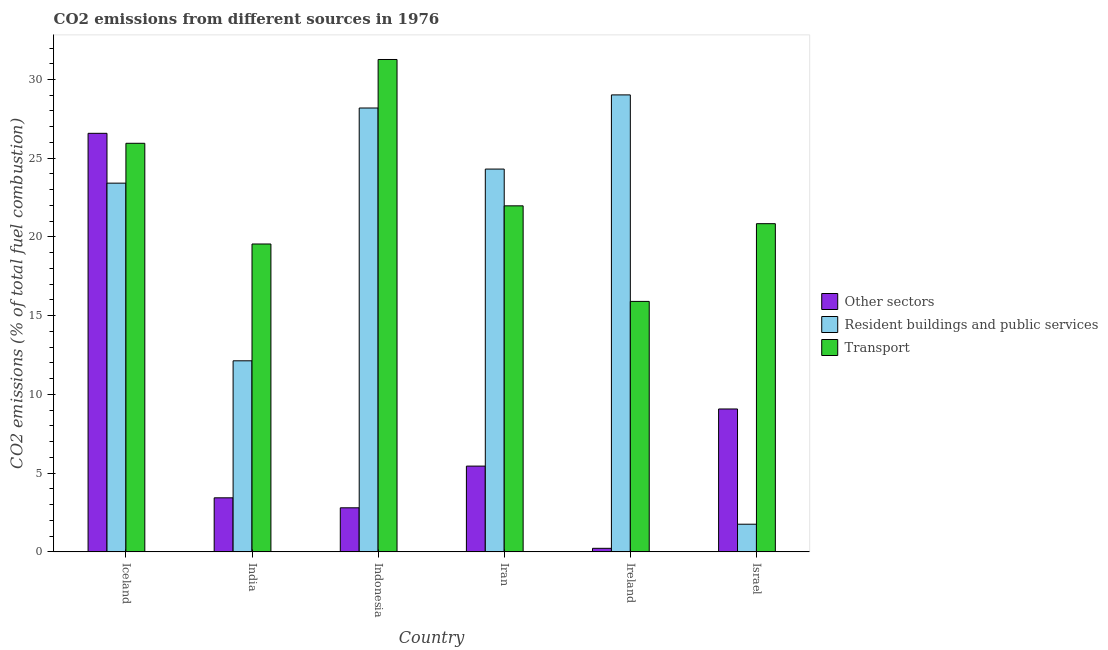How many different coloured bars are there?
Make the answer very short. 3. How many groups of bars are there?
Provide a succinct answer. 6. Are the number of bars per tick equal to the number of legend labels?
Provide a succinct answer. Yes. Are the number of bars on each tick of the X-axis equal?
Keep it short and to the point. Yes. How many bars are there on the 6th tick from the right?
Offer a terse response. 3. What is the label of the 6th group of bars from the left?
Provide a succinct answer. Israel. What is the percentage of co2 emissions from transport in Indonesia?
Your response must be concise. 31.27. Across all countries, what is the maximum percentage of co2 emissions from transport?
Give a very brief answer. 31.27. Across all countries, what is the minimum percentage of co2 emissions from transport?
Your response must be concise. 15.91. In which country was the percentage of co2 emissions from resident buildings and public services maximum?
Your response must be concise. Ireland. In which country was the percentage of co2 emissions from resident buildings and public services minimum?
Provide a succinct answer. Israel. What is the total percentage of co2 emissions from other sectors in the graph?
Your response must be concise. 47.56. What is the difference between the percentage of co2 emissions from transport in Indonesia and that in Israel?
Provide a short and direct response. 10.43. What is the difference between the percentage of co2 emissions from transport in Iran and the percentage of co2 emissions from other sectors in India?
Give a very brief answer. 18.54. What is the average percentage of co2 emissions from other sectors per country?
Your response must be concise. 7.93. What is the difference between the percentage of co2 emissions from other sectors and percentage of co2 emissions from transport in Iceland?
Provide a succinct answer. 0.63. What is the ratio of the percentage of co2 emissions from resident buildings and public services in Iceland to that in Indonesia?
Your answer should be very brief. 0.83. Is the difference between the percentage of co2 emissions from resident buildings and public services in India and Ireland greater than the difference between the percentage of co2 emissions from transport in India and Ireland?
Provide a short and direct response. No. What is the difference between the highest and the second highest percentage of co2 emissions from other sectors?
Your answer should be compact. 17.51. What is the difference between the highest and the lowest percentage of co2 emissions from transport?
Provide a succinct answer. 15.36. In how many countries, is the percentage of co2 emissions from other sectors greater than the average percentage of co2 emissions from other sectors taken over all countries?
Offer a terse response. 2. What does the 2nd bar from the left in Israel represents?
Offer a very short reply. Resident buildings and public services. What does the 2nd bar from the right in Israel represents?
Offer a terse response. Resident buildings and public services. Are all the bars in the graph horizontal?
Keep it short and to the point. No. How many countries are there in the graph?
Offer a very short reply. 6. Are the values on the major ticks of Y-axis written in scientific E-notation?
Your answer should be compact. No. What is the title of the graph?
Offer a very short reply. CO2 emissions from different sources in 1976. Does "Infant(male)" appear as one of the legend labels in the graph?
Your answer should be compact. No. What is the label or title of the X-axis?
Offer a very short reply. Country. What is the label or title of the Y-axis?
Your answer should be very brief. CO2 emissions (% of total fuel combustion). What is the CO2 emissions (% of total fuel combustion) of Other sectors in Iceland?
Ensure brevity in your answer.  26.58. What is the CO2 emissions (% of total fuel combustion) in Resident buildings and public services in Iceland?
Offer a very short reply. 23.42. What is the CO2 emissions (% of total fuel combustion) of Transport in Iceland?
Keep it short and to the point. 25.95. What is the CO2 emissions (% of total fuel combustion) in Other sectors in India?
Your answer should be compact. 3.43. What is the CO2 emissions (% of total fuel combustion) of Resident buildings and public services in India?
Your response must be concise. 12.13. What is the CO2 emissions (% of total fuel combustion) of Transport in India?
Provide a succinct answer. 19.55. What is the CO2 emissions (% of total fuel combustion) in Other sectors in Indonesia?
Provide a succinct answer. 2.8. What is the CO2 emissions (% of total fuel combustion) in Resident buildings and public services in Indonesia?
Keep it short and to the point. 28.19. What is the CO2 emissions (% of total fuel combustion) in Transport in Indonesia?
Provide a succinct answer. 31.27. What is the CO2 emissions (% of total fuel combustion) in Other sectors in Iran?
Make the answer very short. 5.45. What is the CO2 emissions (% of total fuel combustion) of Resident buildings and public services in Iran?
Ensure brevity in your answer.  24.31. What is the CO2 emissions (% of total fuel combustion) of Transport in Iran?
Keep it short and to the point. 21.98. What is the CO2 emissions (% of total fuel combustion) of Other sectors in Ireland?
Make the answer very short. 0.23. What is the CO2 emissions (% of total fuel combustion) of Resident buildings and public services in Ireland?
Offer a terse response. 29.02. What is the CO2 emissions (% of total fuel combustion) of Transport in Ireland?
Your answer should be very brief. 15.91. What is the CO2 emissions (% of total fuel combustion) of Other sectors in Israel?
Ensure brevity in your answer.  9.07. What is the CO2 emissions (% of total fuel combustion) of Resident buildings and public services in Israel?
Make the answer very short. 1.76. What is the CO2 emissions (% of total fuel combustion) in Transport in Israel?
Offer a terse response. 20.84. Across all countries, what is the maximum CO2 emissions (% of total fuel combustion) of Other sectors?
Your answer should be compact. 26.58. Across all countries, what is the maximum CO2 emissions (% of total fuel combustion) in Resident buildings and public services?
Your answer should be compact. 29.02. Across all countries, what is the maximum CO2 emissions (% of total fuel combustion) in Transport?
Your answer should be very brief. 31.27. Across all countries, what is the minimum CO2 emissions (% of total fuel combustion) of Other sectors?
Keep it short and to the point. 0.23. Across all countries, what is the minimum CO2 emissions (% of total fuel combustion) of Resident buildings and public services?
Give a very brief answer. 1.76. Across all countries, what is the minimum CO2 emissions (% of total fuel combustion) in Transport?
Your answer should be compact. 15.91. What is the total CO2 emissions (% of total fuel combustion) in Other sectors in the graph?
Offer a very short reply. 47.56. What is the total CO2 emissions (% of total fuel combustion) in Resident buildings and public services in the graph?
Provide a succinct answer. 118.83. What is the total CO2 emissions (% of total fuel combustion) of Transport in the graph?
Offer a very short reply. 135.5. What is the difference between the CO2 emissions (% of total fuel combustion) of Other sectors in Iceland and that in India?
Give a very brief answer. 23.15. What is the difference between the CO2 emissions (% of total fuel combustion) in Resident buildings and public services in Iceland and that in India?
Keep it short and to the point. 11.28. What is the difference between the CO2 emissions (% of total fuel combustion) of Transport in Iceland and that in India?
Offer a very short reply. 6.4. What is the difference between the CO2 emissions (% of total fuel combustion) in Other sectors in Iceland and that in Indonesia?
Your response must be concise. 23.78. What is the difference between the CO2 emissions (% of total fuel combustion) of Resident buildings and public services in Iceland and that in Indonesia?
Keep it short and to the point. -4.77. What is the difference between the CO2 emissions (% of total fuel combustion) of Transport in Iceland and that in Indonesia?
Provide a succinct answer. -5.32. What is the difference between the CO2 emissions (% of total fuel combustion) of Other sectors in Iceland and that in Iran?
Ensure brevity in your answer.  21.13. What is the difference between the CO2 emissions (% of total fuel combustion) in Resident buildings and public services in Iceland and that in Iran?
Offer a very short reply. -0.89. What is the difference between the CO2 emissions (% of total fuel combustion) of Transport in Iceland and that in Iran?
Provide a succinct answer. 3.97. What is the difference between the CO2 emissions (% of total fuel combustion) of Other sectors in Iceland and that in Ireland?
Make the answer very short. 26.36. What is the difference between the CO2 emissions (% of total fuel combustion) of Resident buildings and public services in Iceland and that in Ireland?
Your answer should be very brief. -5.6. What is the difference between the CO2 emissions (% of total fuel combustion) of Transport in Iceland and that in Ireland?
Your response must be concise. 10.04. What is the difference between the CO2 emissions (% of total fuel combustion) of Other sectors in Iceland and that in Israel?
Your answer should be compact. 17.51. What is the difference between the CO2 emissions (% of total fuel combustion) in Resident buildings and public services in Iceland and that in Israel?
Offer a very short reply. 21.66. What is the difference between the CO2 emissions (% of total fuel combustion) in Transport in Iceland and that in Israel?
Make the answer very short. 5.11. What is the difference between the CO2 emissions (% of total fuel combustion) of Other sectors in India and that in Indonesia?
Your answer should be very brief. 0.63. What is the difference between the CO2 emissions (% of total fuel combustion) in Resident buildings and public services in India and that in Indonesia?
Ensure brevity in your answer.  -16.06. What is the difference between the CO2 emissions (% of total fuel combustion) of Transport in India and that in Indonesia?
Your answer should be compact. -11.72. What is the difference between the CO2 emissions (% of total fuel combustion) of Other sectors in India and that in Iran?
Give a very brief answer. -2.02. What is the difference between the CO2 emissions (% of total fuel combustion) in Resident buildings and public services in India and that in Iran?
Offer a very short reply. -12.18. What is the difference between the CO2 emissions (% of total fuel combustion) of Transport in India and that in Iran?
Offer a very short reply. -2.42. What is the difference between the CO2 emissions (% of total fuel combustion) of Other sectors in India and that in Ireland?
Your response must be concise. 3.21. What is the difference between the CO2 emissions (% of total fuel combustion) of Resident buildings and public services in India and that in Ireland?
Your answer should be compact. -16.89. What is the difference between the CO2 emissions (% of total fuel combustion) of Transport in India and that in Ireland?
Make the answer very short. 3.65. What is the difference between the CO2 emissions (% of total fuel combustion) of Other sectors in India and that in Israel?
Provide a short and direct response. -5.64. What is the difference between the CO2 emissions (% of total fuel combustion) of Resident buildings and public services in India and that in Israel?
Make the answer very short. 10.38. What is the difference between the CO2 emissions (% of total fuel combustion) in Transport in India and that in Israel?
Your answer should be compact. -1.29. What is the difference between the CO2 emissions (% of total fuel combustion) in Other sectors in Indonesia and that in Iran?
Offer a terse response. -2.65. What is the difference between the CO2 emissions (% of total fuel combustion) in Resident buildings and public services in Indonesia and that in Iran?
Provide a short and direct response. 3.88. What is the difference between the CO2 emissions (% of total fuel combustion) of Transport in Indonesia and that in Iran?
Your response must be concise. 9.29. What is the difference between the CO2 emissions (% of total fuel combustion) of Other sectors in Indonesia and that in Ireland?
Your answer should be very brief. 2.57. What is the difference between the CO2 emissions (% of total fuel combustion) in Resident buildings and public services in Indonesia and that in Ireland?
Give a very brief answer. -0.83. What is the difference between the CO2 emissions (% of total fuel combustion) in Transport in Indonesia and that in Ireland?
Make the answer very short. 15.36. What is the difference between the CO2 emissions (% of total fuel combustion) in Other sectors in Indonesia and that in Israel?
Your answer should be very brief. -6.28. What is the difference between the CO2 emissions (% of total fuel combustion) of Resident buildings and public services in Indonesia and that in Israel?
Offer a terse response. 26.43. What is the difference between the CO2 emissions (% of total fuel combustion) in Transport in Indonesia and that in Israel?
Your answer should be compact. 10.43. What is the difference between the CO2 emissions (% of total fuel combustion) in Other sectors in Iran and that in Ireland?
Your answer should be compact. 5.22. What is the difference between the CO2 emissions (% of total fuel combustion) in Resident buildings and public services in Iran and that in Ireland?
Make the answer very short. -4.71. What is the difference between the CO2 emissions (% of total fuel combustion) in Transport in Iran and that in Ireland?
Your response must be concise. 6.07. What is the difference between the CO2 emissions (% of total fuel combustion) of Other sectors in Iran and that in Israel?
Your answer should be compact. -3.63. What is the difference between the CO2 emissions (% of total fuel combustion) of Resident buildings and public services in Iran and that in Israel?
Offer a very short reply. 22.55. What is the difference between the CO2 emissions (% of total fuel combustion) of Transport in Iran and that in Israel?
Your response must be concise. 1.13. What is the difference between the CO2 emissions (% of total fuel combustion) in Other sectors in Ireland and that in Israel?
Make the answer very short. -8.85. What is the difference between the CO2 emissions (% of total fuel combustion) of Resident buildings and public services in Ireland and that in Israel?
Give a very brief answer. 27.27. What is the difference between the CO2 emissions (% of total fuel combustion) of Transport in Ireland and that in Israel?
Ensure brevity in your answer.  -4.93. What is the difference between the CO2 emissions (% of total fuel combustion) of Other sectors in Iceland and the CO2 emissions (% of total fuel combustion) of Resident buildings and public services in India?
Offer a very short reply. 14.45. What is the difference between the CO2 emissions (% of total fuel combustion) of Other sectors in Iceland and the CO2 emissions (% of total fuel combustion) of Transport in India?
Give a very brief answer. 7.03. What is the difference between the CO2 emissions (% of total fuel combustion) of Resident buildings and public services in Iceland and the CO2 emissions (% of total fuel combustion) of Transport in India?
Make the answer very short. 3.86. What is the difference between the CO2 emissions (% of total fuel combustion) of Other sectors in Iceland and the CO2 emissions (% of total fuel combustion) of Resident buildings and public services in Indonesia?
Ensure brevity in your answer.  -1.61. What is the difference between the CO2 emissions (% of total fuel combustion) of Other sectors in Iceland and the CO2 emissions (% of total fuel combustion) of Transport in Indonesia?
Provide a succinct answer. -4.69. What is the difference between the CO2 emissions (% of total fuel combustion) of Resident buildings and public services in Iceland and the CO2 emissions (% of total fuel combustion) of Transport in Indonesia?
Your answer should be very brief. -7.85. What is the difference between the CO2 emissions (% of total fuel combustion) in Other sectors in Iceland and the CO2 emissions (% of total fuel combustion) in Resident buildings and public services in Iran?
Your answer should be very brief. 2.27. What is the difference between the CO2 emissions (% of total fuel combustion) of Other sectors in Iceland and the CO2 emissions (% of total fuel combustion) of Transport in Iran?
Keep it short and to the point. 4.61. What is the difference between the CO2 emissions (% of total fuel combustion) of Resident buildings and public services in Iceland and the CO2 emissions (% of total fuel combustion) of Transport in Iran?
Provide a succinct answer. 1.44. What is the difference between the CO2 emissions (% of total fuel combustion) in Other sectors in Iceland and the CO2 emissions (% of total fuel combustion) in Resident buildings and public services in Ireland?
Your response must be concise. -2.44. What is the difference between the CO2 emissions (% of total fuel combustion) of Other sectors in Iceland and the CO2 emissions (% of total fuel combustion) of Transport in Ireland?
Provide a succinct answer. 10.67. What is the difference between the CO2 emissions (% of total fuel combustion) in Resident buildings and public services in Iceland and the CO2 emissions (% of total fuel combustion) in Transport in Ireland?
Offer a very short reply. 7.51. What is the difference between the CO2 emissions (% of total fuel combustion) of Other sectors in Iceland and the CO2 emissions (% of total fuel combustion) of Resident buildings and public services in Israel?
Your answer should be very brief. 24.83. What is the difference between the CO2 emissions (% of total fuel combustion) of Other sectors in Iceland and the CO2 emissions (% of total fuel combustion) of Transport in Israel?
Your answer should be compact. 5.74. What is the difference between the CO2 emissions (% of total fuel combustion) in Resident buildings and public services in Iceland and the CO2 emissions (% of total fuel combustion) in Transport in Israel?
Give a very brief answer. 2.57. What is the difference between the CO2 emissions (% of total fuel combustion) of Other sectors in India and the CO2 emissions (% of total fuel combustion) of Resident buildings and public services in Indonesia?
Offer a very short reply. -24.76. What is the difference between the CO2 emissions (% of total fuel combustion) of Other sectors in India and the CO2 emissions (% of total fuel combustion) of Transport in Indonesia?
Keep it short and to the point. -27.84. What is the difference between the CO2 emissions (% of total fuel combustion) in Resident buildings and public services in India and the CO2 emissions (% of total fuel combustion) in Transport in Indonesia?
Give a very brief answer. -19.14. What is the difference between the CO2 emissions (% of total fuel combustion) in Other sectors in India and the CO2 emissions (% of total fuel combustion) in Resident buildings and public services in Iran?
Ensure brevity in your answer.  -20.88. What is the difference between the CO2 emissions (% of total fuel combustion) of Other sectors in India and the CO2 emissions (% of total fuel combustion) of Transport in Iran?
Keep it short and to the point. -18.54. What is the difference between the CO2 emissions (% of total fuel combustion) in Resident buildings and public services in India and the CO2 emissions (% of total fuel combustion) in Transport in Iran?
Offer a very short reply. -9.84. What is the difference between the CO2 emissions (% of total fuel combustion) in Other sectors in India and the CO2 emissions (% of total fuel combustion) in Resident buildings and public services in Ireland?
Your response must be concise. -25.59. What is the difference between the CO2 emissions (% of total fuel combustion) of Other sectors in India and the CO2 emissions (% of total fuel combustion) of Transport in Ireland?
Provide a succinct answer. -12.48. What is the difference between the CO2 emissions (% of total fuel combustion) in Resident buildings and public services in India and the CO2 emissions (% of total fuel combustion) in Transport in Ireland?
Give a very brief answer. -3.77. What is the difference between the CO2 emissions (% of total fuel combustion) in Other sectors in India and the CO2 emissions (% of total fuel combustion) in Resident buildings and public services in Israel?
Give a very brief answer. 1.68. What is the difference between the CO2 emissions (% of total fuel combustion) in Other sectors in India and the CO2 emissions (% of total fuel combustion) in Transport in Israel?
Give a very brief answer. -17.41. What is the difference between the CO2 emissions (% of total fuel combustion) of Resident buildings and public services in India and the CO2 emissions (% of total fuel combustion) of Transport in Israel?
Your answer should be compact. -8.71. What is the difference between the CO2 emissions (% of total fuel combustion) in Other sectors in Indonesia and the CO2 emissions (% of total fuel combustion) in Resident buildings and public services in Iran?
Offer a terse response. -21.51. What is the difference between the CO2 emissions (% of total fuel combustion) of Other sectors in Indonesia and the CO2 emissions (% of total fuel combustion) of Transport in Iran?
Your answer should be very brief. -19.18. What is the difference between the CO2 emissions (% of total fuel combustion) in Resident buildings and public services in Indonesia and the CO2 emissions (% of total fuel combustion) in Transport in Iran?
Make the answer very short. 6.21. What is the difference between the CO2 emissions (% of total fuel combustion) of Other sectors in Indonesia and the CO2 emissions (% of total fuel combustion) of Resident buildings and public services in Ireland?
Your answer should be very brief. -26.22. What is the difference between the CO2 emissions (% of total fuel combustion) of Other sectors in Indonesia and the CO2 emissions (% of total fuel combustion) of Transport in Ireland?
Provide a succinct answer. -13.11. What is the difference between the CO2 emissions (% of total fuel combustion) in Resident buildings and public services in Indonesia and the CO2 emissions (% of total fuel combustion) in Transport in Ireland?
Give a very brief answer. 12.28. What is the difference between the CO2 emissions (% of total fuel combustion) in Other sectors in Indonesia and the CO2 emissions (% of total fuel combustion) in Resident buildings and public services in Israel?
Provide a succinct answer. 1.04. What is the difference between the CO2 emissions (% of total fuel combustion) in Other sectors in Indonesia and the CO2 emissions (% of total fuel combustion) in Transport in Israel?
Keep it short and to the point. -18.04. What is the difference between the CO2 emissions (% of total fuel combustion) of Resident buildings and public services in Indonesia and the CO2 emissions (% of total fuel combustion) of Transport in Israel?
Give a very brief answer. 7.35. What is the difference between the CO2 emissions (% of total fuel combustion) of Other sectors in Iran and the CO2 emissions (% of total fuel combustion) of Resident buildings and public services in Ireland?
Give a very brief answer. -23.57. What is the difference between the CO2 emissions (% of total fuel combustion) in Other sectors in Iran and the CO2 emissions (% of total fuel combustion) in Transport in Ireland?
Make the answer very short. -10.46. What is the difference between the CO2 emissions (% of total fuel combustion) in Resident buildings and public services in Iran and the CO2 emissions (% of total fuel combustion) in Transport in Ireland?
Offer a very short reply. 8.4. What is the difference between the CO2 emissions (% of total fuel combustion) of Other sectors in Iran and the CO2 emissions (% of total fuel combustion) of Resident buildings and public services in Israel?
Provide a short and direct response. 3.69. What is the difference between the CO2 emissions (% of total fuel combustion) in Other sectors in Iran and the CO2 emissions (% of total fuel combustion) in Transport in Israel?
Offer a terse response. -15.4. What is the difference between the CO2 emissions (% of total fuel combustion) in Resident buildings and public services in Iran and the CO2 emissions (% of total fuel combustion) in Transport in Israel?
Provide a short and direct response. 3.47. What is the difference between the CO2 emissions (% of total fuel combustion) in Other sectors in Ireland and the CO2 emissions (% of total fuel combustion) in Resident buildings and public services in Israel?
Ensure brevity in your answer.  -1.53. What is the difference between the CO2 emissions (% of total fuel combustion) in Other sectors in Ireland and the CO2 emissions (% of total fuel combustion) in Transport in Israel?
Your response must be concise. -20.62. What is the difference between the CO2 emissions (% of total fuel combustion) in Resident buildings and public services in Ireland and the CO2 emissions (% of total fuel combustion) in Transport in Israel?
Make the answer very short. 8.18. What is the average CO2 emissions (% of total fuel combustion) of Other sectors per country?
Your answer should be very brief. 7.93. What is the average CO2 emissions (% of total fuel combustion) of Resident buildings and public services per country?
Provide a succinct answer. 19.81. What is the average CO2 emissions (% of total fuel combustion) of Transport per country?
Keep it short and to the point. 22.58. What is the difference between the CO2 emissions (% of total fuel combustion) of Other sectors and CO2 emissions (% of total fuel combustion) of Resident buildings and public services in Iceland?
Keep it short and to the point. 3.16. What is the difference between the CO2 emissions (% of total fuel combustion) in Other sectors and CO2 emissions (% of total fuel combustion) in Transport in Iceland?
Ensure brevity in your answer.  0.63. What is the difference between the CO2 emissions (% of total fuel combustion) of Resident buildings and public services and CO2 emissions (% of total fuel combustion) of Transport in Iceland?
Your answer should be compact. -2.53. What is the difference between the CO2 emissions (% of total fuel combustion) in Other sectors and CO2 emissions (% of total fuel combustion) in Resident buildings and public services in India?
Ensure brevity in your answer.  -8.7. What is the difference between the CO2 emissions (% of total fuel combustion) in Other sectors and CO2 emissions (% of total fuel combustion) in Transport in India?
Provide a short and direct response. -16.12. What is the difference between the CO2 emissions (% of total fuel combustion) of Resident buildings and public services and CO2 emissions (% of total fuel combustion) of Transport in India?
Give a very brief answer. -7.42. What is the difference between the CO2 emissions (% of total fuel combustion) in Other sectors and CO2 emissions (% of total fuel combustion) in Resident buildings and public services in Indonesia?
Provide a succinct answer. -25.39. What is the difference between the CO2 emissions (% of total fuel combustion) in Other sectors and CO2 emissions (% of total fuel combustion) in Transport in Indonesia?
Ensure brevity in your answer.  -28.47. What is the difference between the CO2 emissions (% of total fuel combustion) in Resident buildings and public services and CO2 emissions (% of total fuel combustion) in Transport in Indonesia?
Make the answer very short. -3.08. What is the difference between the CO2 emissions (% of total fuel combustion) of Other sectors and CO2 emissions (% of total fuel combustion) of Resident buildings and public services in Iran?
Offer a very short reply. -18.86. What is the difference between the CO2 emissions (% of total fuel combustion) of Other sectors and CO2 emissions (% of total fuel combustion) of Transport in Iran?
Your answer should be very brief. -16.53. What is the difference between the CO2 emissions (% of total fuel combustion) of Resident buildings and public services and CO2 emissions (% of total fuel combustion) of Transport in Iran?
Keep it short and to the point. 2.33. What is the difference between the CO2 emissions (% of total fuel combustion) in Other sectors and CO2 emissions (% of total fuel combustion) in Resident buildings and public services in Ireland?
Your answer should be compact. -28.8. What is the difference between the CO2 emissions (% of total fuel combustion) of Other sectors and CO2 emissions (% of total fuel combustion) of Transport in Ireland?
Your response must be concise. -15.68. What is the difference between the CO2 emissions (% of total fuel combustion) in Resident buildings and public services and CO2 emissions (% of total fuel combustion) in Transport in Ireland?
Provide a succinct answer. 13.11. What is the difference between the CO2 emissions (% of total fuel combustion) in Other sectors and CO2 emissions (% of total fuel combustion) in Resident buildings and public services in Israel?
Keep it short and to the point. 7.32. What is the difference between the CO2 emissions (% of total fuel combustion) in Other sectors and CO2 emissions (% of total fuel combustion) in Transport in Israel?
Your answer should be very brief. -11.77. What is the difference between the CO2 emissions (% of total fuel combustion) in Resident buildings and public services and CO2 emissions (% of total fuel combustion) in Transport in Israel?
Make the answer very short. -19.09. What is the ratio of the CO2 emissions (% of total fuel combustion) in Other sectors in Iceland to that in India?
Give a very brief answer. 7.74. What is the ratio of the CO2 emissions (% of total fuel combustion) in Resident buildings and public services in Iceland to that in India?
Offer a very short reply. 1.93. What is the ratio of the CO2 emissions (% of total fuel combustion) of Transport in Iceland to that in India?
Offer a terse response. 1.33. What is the ratio of the CO2 emissions (% of total fuel combustion) in Other sectors in Iceland to that in Indonesia?
Provide a succinct answer. 9.5. What is the ratio of the CO2 emissions (% of total fuel combustion) in Resident buildings and public services in Iceland to that in Indonesia?
Offer a terse response. 0.83. What is the ratio of the CO2 emissions (% of total fuel combustion) in Transport in Iceland to that in Indonesia?
Your answer should be compact. 0.83. What is the ratio of the CO2 emissions (% of total fuel combustion) in Other sectors in Iceland to that in Iran?
Offer a terse response. 4.88. What is the ratio of the CO2 emissions (% of total fuel combustion) in Resident buildings and public services in Iceland to that in Iran?
Your response must be concise. 0.96. What is the ratio of the CO2 emissions (% of total fuel combustion) in Transport in Iceland to that in Iran?
Your answer should be compact. 1.18. What is the ratio of the CO2 emissions (% of total fuel combustion) in Other sectors in Iceland to that in Ireland?
Your response must be concise. 117.97. What is the ratio of the CO2 emissions (% of total fuel combustion) in Resident buildings and public services in Iceland to that in Ireland?
Offer a very short reply. 0.81. What is the ratio of the CO2 emissions (% of total fuel combustion) of Transport in Iceland to that in Ireland?
Your answer should be compact. 1.63. What is the ratio of the CO2 emissions (% of total fuel combustion) of Other sectors in Iceland to that in Israel?
Give a very brief answer. 2.93. What is the ratio of the CO2 emissions (% of total fuel combustion) of Resident buildings and public services in Iceland to that in Israel?
Offer a very short reply. 13.33. What is the ratio of the CO2 emissions (% of total fuel combustion) in Transport in Iceland to that in Israel?
Ensure brevity in your answer.  1.25. What is the ratio of the CO2 emissions (% of total fuel combustion) in Other sectors in India to that in Indonesia?
Offer a very short reply. 1.23. What is the ratio of the CO2 emissions (% of total fuel combustion) in Resident buildings and public services in India to that in Indonesia?
Provide a short and direct response. 0.43. What is the ratio of the CO2 emissions (% of total fuel combustion) of Transport in India to that in Indonesia?
Your answer should be compact. 0.63. What is the ratio of the CO2 emissions (% of total fuel combustion) in Other sectors in India to that in Iran?
Ensure brevity in your answer.  0.63. What is the ratio of the CO2 emissions (% of total fuel combustion) of Resident buildings and public services in India to that in Iran?
Your response must be concise. 0.5. What is the ratio of the CO2 emissions (% of total fuel combustion) in Transport in India to that in Iran?
Your answer should be very brief. 0.89. What is the ratio of the CO2 emissions (% of total fuel combustion) in Other sectors in India to that in Ireland?
Your answer should be very brief. 15.23. What is the ratio of the CO2 emissions (% of total fuel combustion) of Resident buildings and public services in India to that in Ireland?
Keep it short and to the point. 0.42. What is the ratio of the CO2 emissions (% of total fuel combustion) of Transport in India to that in Ireland?
Provide a short and direct response. 1.23. What is the ratio of the CO2 emissions (% of total fuel combustion) in Other sectors in India to that in Israel?
Give a very brief answer. 0.38. What is the ratio of the CO2 emissions (% of total fuel combustion) of Resident buildings and public services in India to that in Israel?
Provide a succinct answer. 6.91. What is the ratio of the CO2 emissions (% of total fuel combustion) of Transport in India to that in Israel?
Offer a terse response. 0.94. What is the ratio of the CO2 emissions (% of total fuel combustion) in Other sectors in Indonesia to that in Iran?
Make the answer very short. 0.51. What is the ratio of the CO2 emissions (% of total fuel combustion) in Resident buildings and public services in Indonesia to that in Iran?
Your answer should be compact. 1.16. What is the ratio of the CO2 emissions (% of total fuel combustion) of Transport in Indonesia to that in Iran?
Keep it short and to the point. 1.42. What is the ratio of the CO2 emissions (% of total fuel combustion) of Other sectors in Indonesia to that in Ireland?
Provide a succinct answer. 12.42. What is the ratio of the CO2 emissions (% of total fuel combustion) of Resident buildings and public services in Indonesia to that in Ireland?
Ensure brevity in your answer.  0.97. What is the ratio of the CO2 emissions (% of total fuel combustion) in Transport in Indonesia to that in Ireland?
Keep it short and to the point. 1.97. What is the ratio of the CO2 emissions (% of total fuel combustion) of Other sectors in Indonesia to that in Israel?
Provide a short and direct response. 0.31. What is the ratio of the CO2 emissions (% of total fuel combustion) of Resident buildings and public services in Indonesia to that in Israel?
Keep it short and to the point. 16.05. What is the ratio of the CO2 emissions (% of total fuel combustion) of Transport in Indonesia to that in Israel?
Give a very brief answer. 1.5. What is the ratio of the CO2 emissions (% of total fuel combustion) of Other sectors in Iran to that in Ireland?
Your answer should be very brief. 24.18. What is the ratio of the CO2 emissions (% of total fuel combustion) of Resident buildings and public services in Iran to that in Ireland?
Keep it short and to the point. 0.84. What is the ratio of the CO2 emissions (% of total fuel combustion) of Transport in Iran to that in Ireland?
Give a very brief answer. 1.38. What is the ratio of the CO2 emissions (% of total fuel combustion) of Other sectors in Iran to that in Israel?
Give a very brief answer. 0.6. What is the ratio of the CO2 emissions (% of total fuel combustion) of Resident buildings and public services in Iran to that in Israel?
Your response must be concise. 13.84. What is the ratio of the CO2 emissions (% of total fuel combustion) of Transport in Iran to that in Israel?
Your answer should be very brief. 1.05. What is the ratio of the CO2 emissions (% of total fuel combustion) in Other sectors in Ireland to that in Israel?
Your answer should be very brief. 0.02. What is the ratio of the CO2 emissions (% of total fuel combustion) of Resident buildings and public services in Ireland to that in Israel?
Your answer should be very brief. 16.52. What is the ratio of the CO2 emissions (% of total fuel combustion) of Transport in Ireland to that in Israel?
Give a very brief answer. 0.76. What is the difference between the highest and the second highest CO2 emissions (% of total fuel combustion) of Other sectors?
Your answer should be compact. 17.51. What is the difference between the highest and the second highest CO2 emissions (% of total fuel combustion) in Resident buildings and public services?
Make the answer very short. 0.83. What is the difference between the highest and the second highest CO2 emissions (% of total fuel combustion) of Transport?
Give a very brief answer. 5.32. What is the difference between the highest and the lowest CO2 emissions (% of total fuel combustion) in Other sectors?
Your response must be concise. 26.36. What is the difference between the highest and the lowest CO2 emissions (% of total fuel combustion) of Resident buildings and public services?
Your answer should be compact. 27.27. What is the difference between the highest and the lowest CO2 emissions (% of total fuel combustion) of Transport?
Keep it short and to the point. 15.36. 